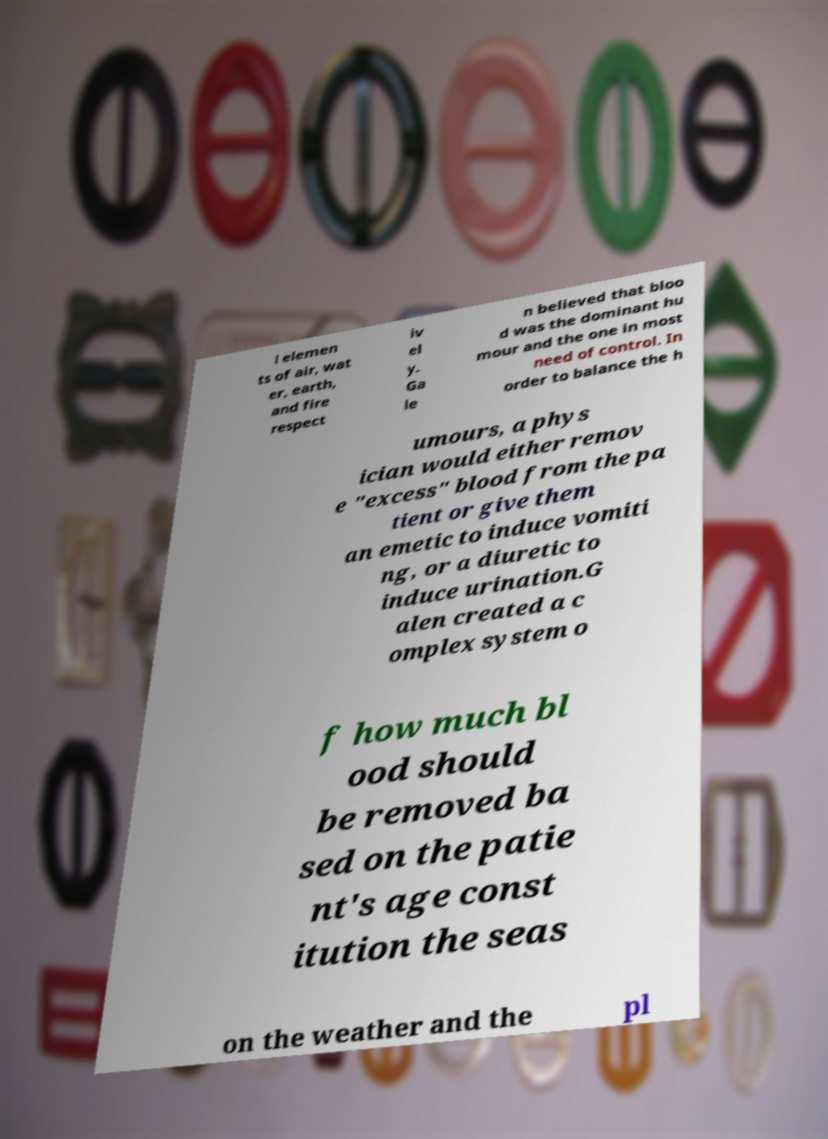Please read and relay the text visible in this image. What does it say? l elemen ts of air, wat er, earth, and fire respect iv el y. Ga le n believed that bloo d was the dominant hu mour and the one in most need of control. In order to balance the h umours, a phys ician would either remov e "excess" blood from the pa tient or give them an emetic to induce vomiti ng, or a diuretic to induce urination.G alen created a c omplex system o f how much bl ood should be removed ba sed on the patie nt's age const itution the seas on the weather and the pl 